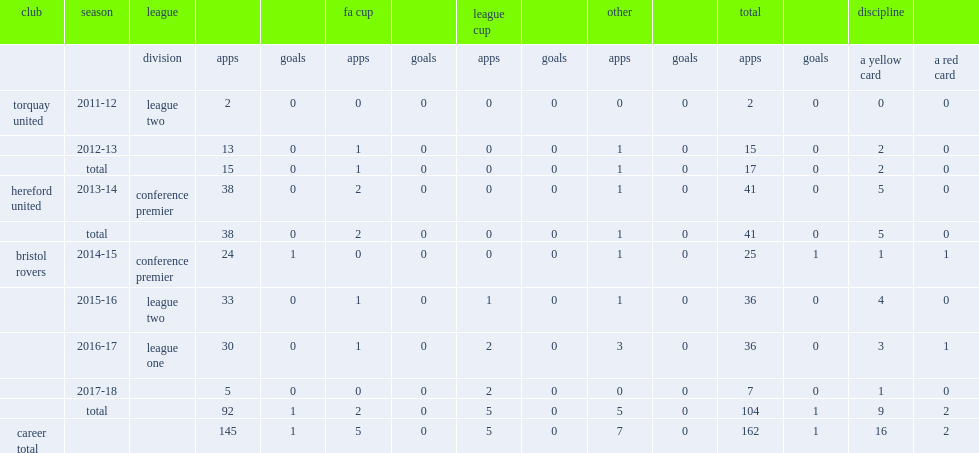How many goals did leadbitter score when he appeared for the conference premier side bristol rovers in the 2014-15 season? 1.0. 